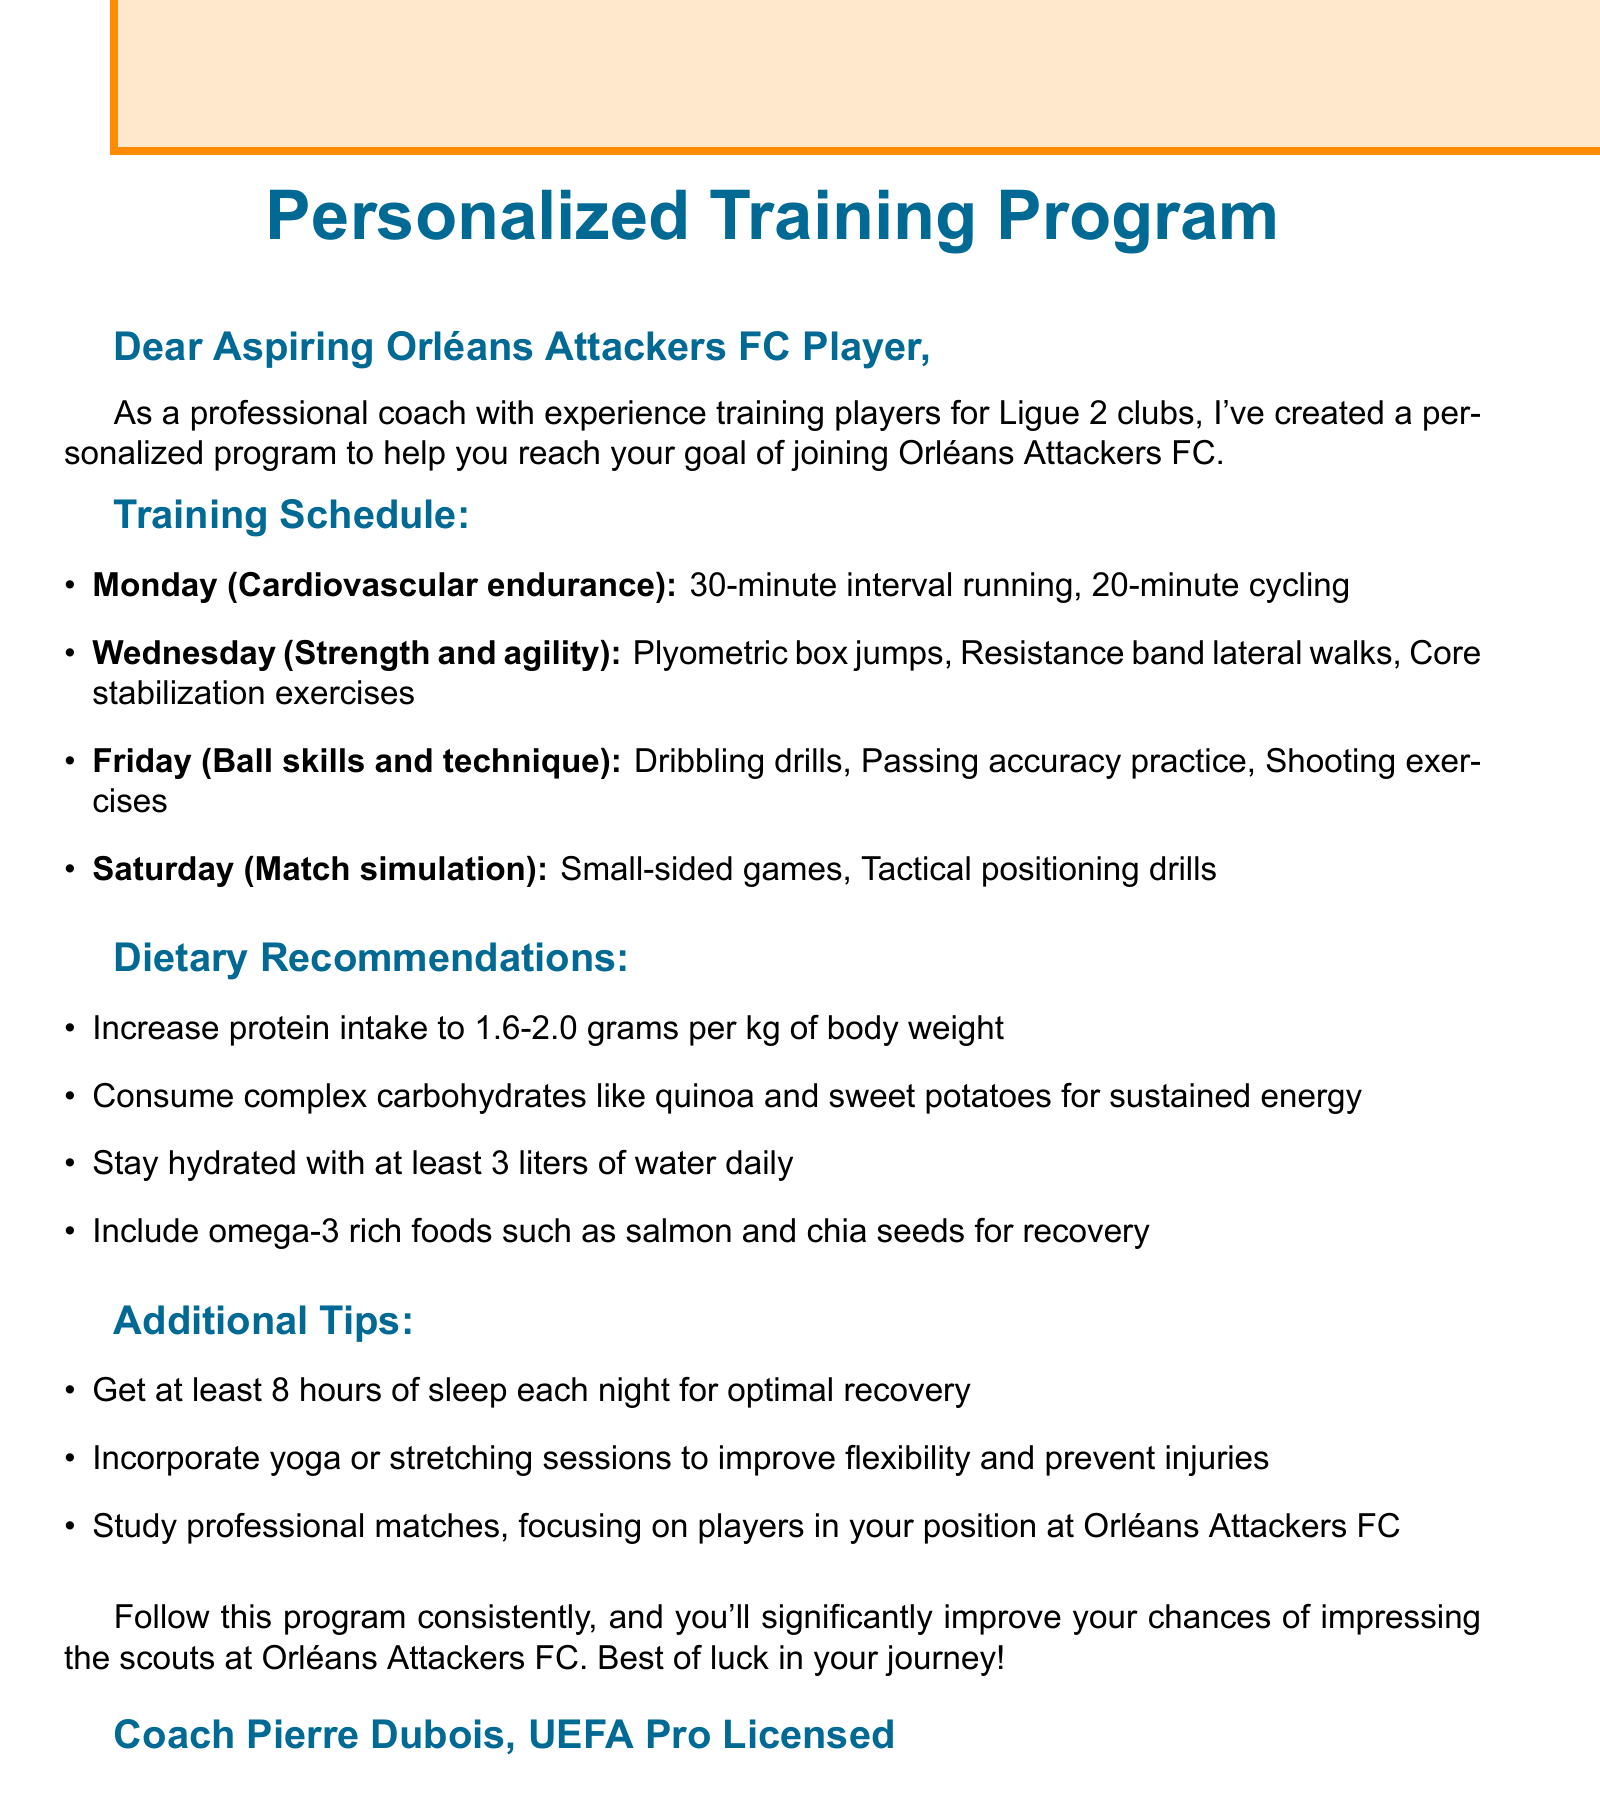What is the coach's name? The coach's name is mentioned at the end of the document.
Answer: Coach Pierre Dubois How many days are included in the training schedule? The training schedule outlines exercises for four days of the week.
Answer: Four What day focuses on ball skills and technique? The document states the specific day allocated for ball skills and technique.
Answer: Friday What should be the daily water intake? The dietary recommendations specify the amount of water to be consumed daily.
Answer: At least 3 liters What is the focus of Wednesday's training? The document lists the focus of training on Wednesday, which includes multiple exercises.
Answer: Strength and agility How many hours of sleep are recommended each night? The additional tips section indicates the recommended amount of sleep for optimal recovery.
Answer: At least 8 hours What type of carbohydrates are suggested for sustained energy? The dietary recommendations highlight a specific kind of carbohydrates for energy.
Answer: Complex carbohydrates What is one of the dietary recommendations to include for recovery? The document specifies a type of food rich in omega-3 for recovery.
Answer: Salmon 